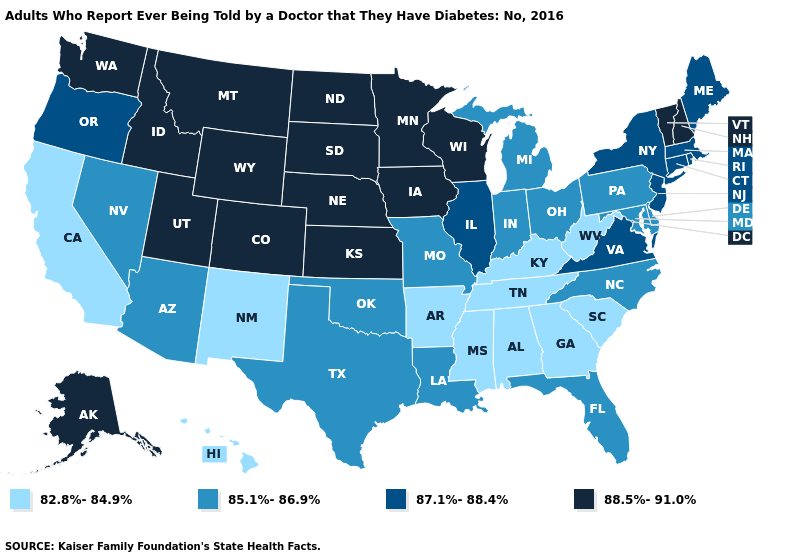Name the states that have a value in the range 87.1%-88.4%?
Quick response, please. Connecticut, Illinois, Maine, Massachusetts, New Jersey, New York, Oregon, Rhode Island, Virginia. Which states have the lowest value in the USA?
Write a very short answer. Alabama, Arkansas, California, Georgia, Hawaii, Kentucky, Mississippi, New Mexico, South Carolina, Tennessee, West Virginia. Among the states that border Kentucky , which have the lowest value?
Short answer required. Tennessee, West Virginia. What is the value of Arizona?
Concise answer only. 85.1%-86.9%. What is the highest value in the USA?
Write a very short answer. 88.5%-91.0%. Does Pennsylvania have the lowest value in the Northeast?
Short answer required. Yes. Is the legend a continuous bar?
Concise answer only. No. What is the value of Wisconsin?
Write a very short answer. 88.5%-91.0%. What is the lowest value in the USA?
Concise answer only. 82.8%-84.9%. What is the value of Maine?
Quick response, please. 87.1%-88.4%. What is the value of Indiana?
Give a very brief answer. 85.1%-86.9%. Among the states that border North Dakota , which have the lowest value?
Keep it brief. Minnesota, Montana, South Dakota. Name the states that have a value in the range 82.8%-84.9%?
Keep it brief. Alabama, Arkansas, California, Georgia, Hawaii, Kentucky, Mississippi, New Mexico, South Carolina, Tennessee, West Virginia. Name the states that have a value in the range 82.8%-84.9%?
Concise answer only. Alabama, Arkansas, California, Georgia, Hawaii, Kentucky, Mississippi, New Mexico, South Carolina, Tennessee, West Virginia. Name the states that have a value in the range 82.8%-84.9%?
Keep it brief. Alabama, Arkansas, California, Georgia, Hawaii, Kentucky, Mississippi, New Mexico, South Carolina, Tennessee, West Virginia. 